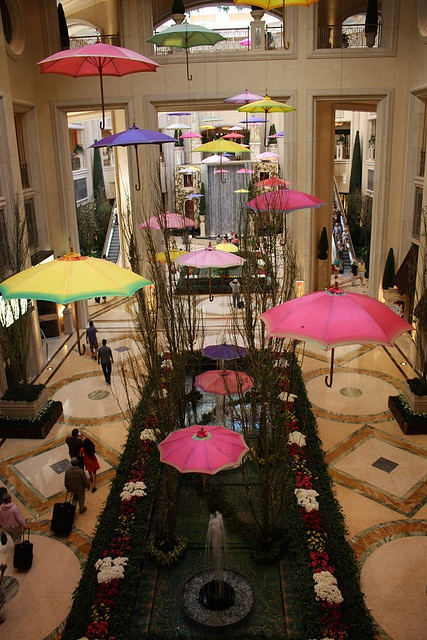Describe the objects in this image and their specific colors. I can see umbrella in black, salmon, and brown tones, umbrella in black, khaki, lightgreen, and tan tones, umbrella in black and brown tones, umbrella in black, brown, salmon, maroon, and lightpink tones, and umbrella in black, pink, lightpink, tan, and khaki tones in this image. 